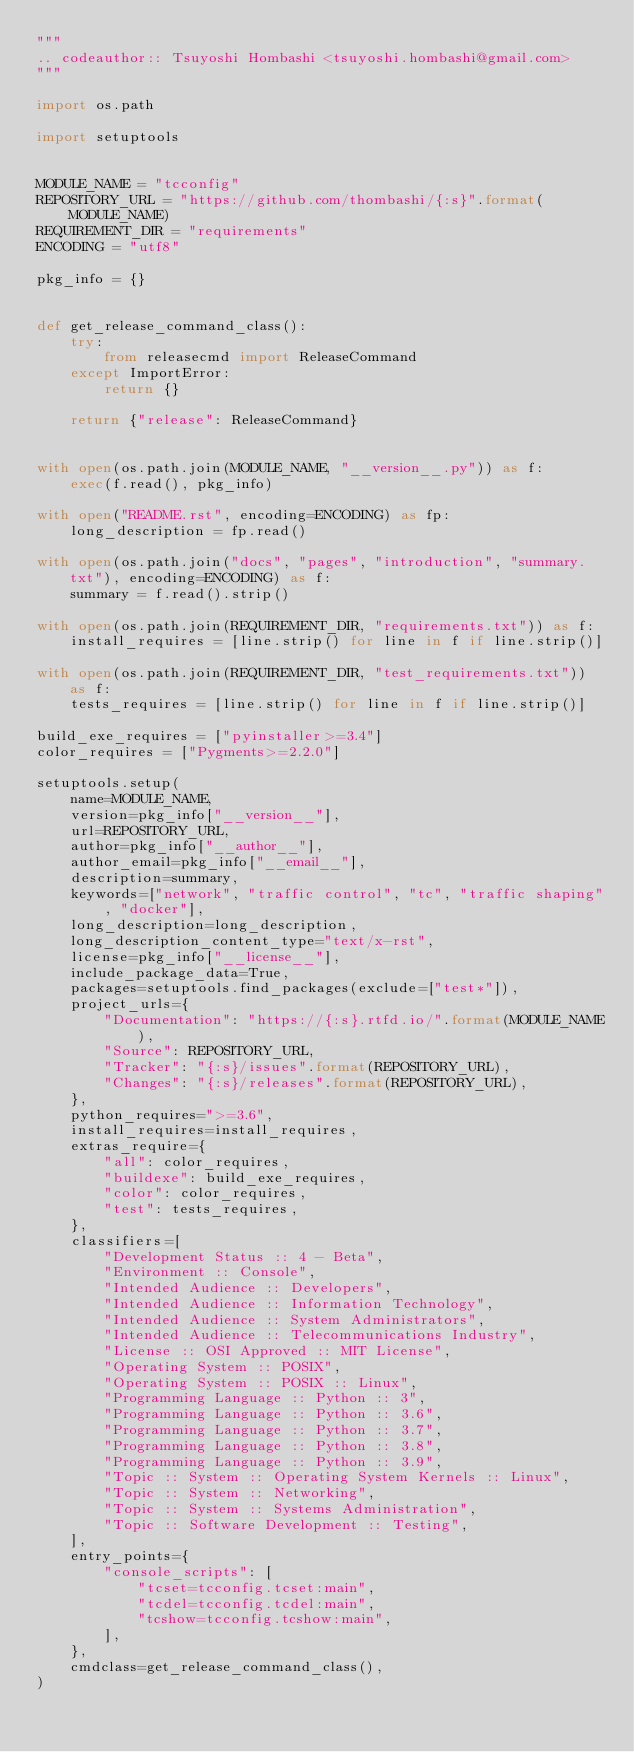Convert code to text. <code><loc_0><loc_0><loc_500><loc_500><_Python_>"""
.. codeauthor:: Tsuyoshi Hombashi <tsuyoshi.hombashi@gmail.com>
"""

import os.path

import setuptools


MODULE_NAME = "tcconfig"
REPOSITORY_URL = "https://github.com/thombashi/{:s}".format(MODULE_NAME)
REQUIREMENT_DIR = "requirements"
ENCODING = "utf8"

pkg_info = {}


def get_release_command_class():
    try:
        from releasecmd import ReleaseCommand
    except ImportError:
        return {}

    return {"release": ReleaseCommand}


with open(os.path.join(MODULE_NAME, "__version__.py")) as f:
    exec(f.read(), pkg_info)

with open("README.rst", encoding=ENCODING) as fp:
    long_description = fp.read()

with open(os.path.join("docs", "pages", "introduction", "summary.txt"), encoding=ENCODING) as f:
    summary = f.read().strip()

with open(os.path.join(REQUIREMENT_DIR, "requirements.txt")) as f:
    install_requires = [line.strip() for line in f if line.strip()]

with open(os.path.join(REQUIREMENT_DIR, "test_requirements.txt")) as f:
    tests_requires = [line.strip() for line in f if line.strip()]

build_exe_requires = ["pyinstaller>=3.4"]
color_requires = ["Pygments>=2.2.0"]

setuptools.setup(
    name=MODULE_NAME,
    version=pkg_info["__version__"],
    url=REPOSITORY_URL,
    author=pkg_info["__author__"],
    author_email=pkg_info["__email__"],
    description=summary,
    keywords=["network", "traffic control", "tc", "traffic shaping", "docker"],
    long_description=long_description,
    long_description_content_type="text/x-rst",
    license=pkg_info["__license__"],
    include_package_data=True,
    packages=setuptools.find_packages(exclude=["test*"]),
    project_urls={
        "Documentation": "https://{:s}.rtfd.io/".format(MODULE_NAME),
        "Source": REPOSITORY_URL,
        "Tracker": "{:s}/issues".format(REPOSITORY_URL),
        "Changes": "{:s}/releases".format(REPOSITORY_URL),
    },
    python_requires=">=3.6",
    install_requires=install_requires,
    extras_require={
        "all": color_requires,
        "buildexe": build_exe_requires,
        "color": color_requires,
        "test": tests_requires,
    },
    classifiers=[
        "Development Status :: 4 - Beta",
        "Environment :: Console",
        "Intended Audience :: Developers",
        "Intended Audience :: Information Technology",
        "Intended Audience :: System Administrators",
        "Intended Audience :: Telecommunications Industry",
        "License :: OSI Approved :: MIT License",
        "Operating System :: POSIX",
        "Operating System :: POSIX :: Linux",
        "Programming Language :: Python :: 3",
        "Programming Language :: Python :: 3.6",
        "Programming Language :: Python :: 3.7",
        "Programming Language :: Python :: 3.8",
        "Programming Language :: Python :: 3.9",
        "Topic :: System :: Operating System Kernels :: Linux",
        "Topic :: System :: Networking",
        "Topic :: System :: Systems Administration",
        "Topic :: Software Development :: Testing",
    ],
    entry_points={
        "console_scripts": [
            "tcset=tcconfig.tcset:main",
            "tcdel=tcconfig.tcdel:main",
            "tcshow=tcconfig.tcshow:main",
        ],
    },
    cmdclass=get_release_command_class(),
)
</code> 